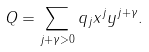<formula> <loc_0><loc_0><loc_500><loc_500>Q = \sum _ { j + \gamma > 0 } q _ { j } x ^ { j } y ^ { j + \gamma } .</formula> 